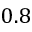<formula> <loc_0><loc_0><loc_500><loc_500>0 . 8</formula> 